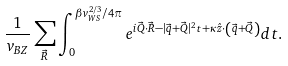<formula> <loc_0><loc_0><loc_500><loc_500>\frac { 1 } { v _ { B Z } } \sum _ { \vec { R } } \int _ { 0 } ^ { \beta v _ { W S } ^ { 2 / 3 } / 4 \pi } e ^ { i \vec { Q } \cdot \vec { R } - | \vec { q } + \vec { Q } | ^ { 2 } t + \kappa \hat { z } \cdot \left ( \vec { q } + \vec { Q } \right ) } d t .</formula> 